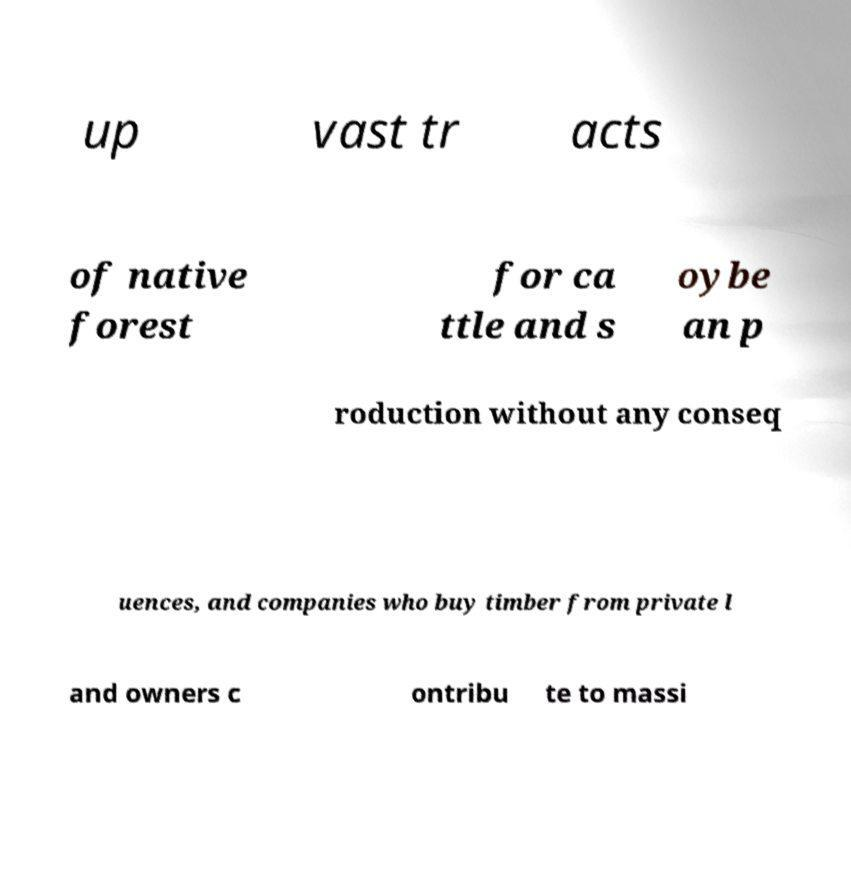Could you extract and type out the text from this image? up vast tr acts of native forest for ca ttle and s oybe an p roduction without any conseq uences, and companies who buy timber from private l and owners c ontribu te to massi 